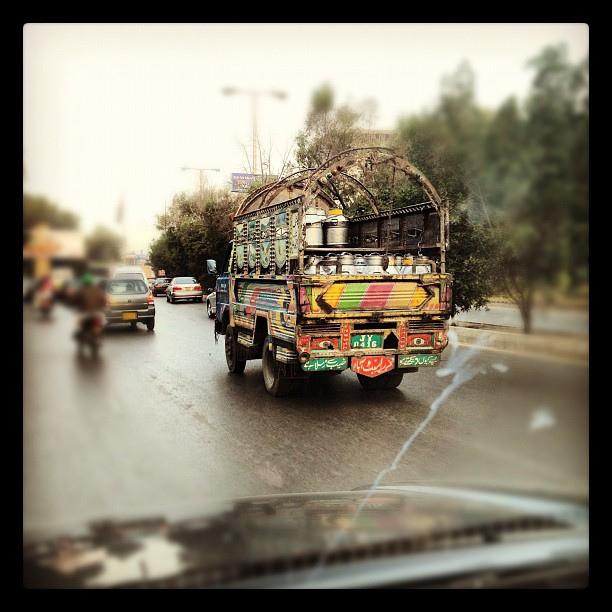Is it rainy out?
Quick response, please. Yes. Is it an American truck?
Quick response, please. No. Is that a beer truck?
Write a very short answer. No. 